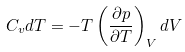Convert formula to latex. <formula><loc_0><loc_0><loc_500><loc_500>C _ { v } d T = - T \left ( \frac { \partial p } { \partial T } \right ) _ { V } d V</formula> 